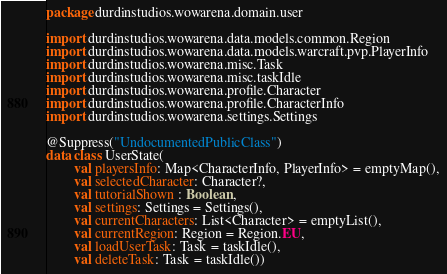<code> <loc_0><loc_0><loc_500><loc_500><_Kotlin_>package durdinstudios.wowarena.domain.user

import durdinstudios.wowarena.data.models.common.Region
import durdinstudios.wowarena.data.models.warcraft.pvp.PlayerInfo
import durdinstudios.wowarena.misc.Task
import durdinstudios.wowarena.misc.taskIdle
import durdinstudios.wowarena.profile.Character
import durdinstudios.wowarena.profile.CharacterInfo
import durdinstudios.wowarena.settings.Settings

@Suppress("UndocumentedPublicClass")
data class UserState(
        val playersInfo: Map<CharacterInfo, PlayerInfo> = emptyMap(),
        val selectedCharacter: Character?,
        val tutorialShown : Boolean,
        val settings: Settings = Settings(),
        val currentCharacters: List<Character> = emptyList(),
        val currentRegion: Region = Region.EU,
        val loadUserTask: Task = taskIdle(),
        val deleteTask: Task = taskIdle())
</code> 